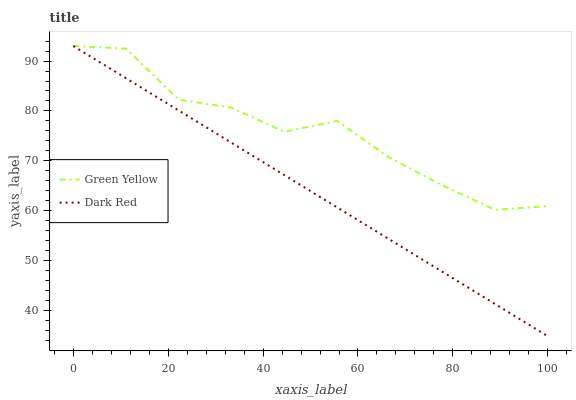Does Dark Red have the minimum area under the curve?
Answer yes or no. Yes. Does Green Yellow have the maximum area under the curve?
Answer yes or no. Yes. Does Green Yellow have the minimum area under the curve?
Answer yes or no. No. Is Dark Red the smoothest?
Answer yes or no. Yes. Is Green Yellow the roughest?
Answer yes or no. Yes. Is Green Yellow the smoothest?
Answer yes or no. No. Does Dark Red have the lowest value?
Answer yes or no. Yes. Does Green Yellow have the lowest value?
Answer yes or no. No. Does Green Yellow have the highest value?
Answer yes or no. Yes. Does Green Yellow intersect Dark Red?
Answer yes or no. Yes. Is Green Yellow less than Dark Red?
Answer yes or no. No. Is Green Yellow greater than Dark Red?
Answer yes or no. No. 